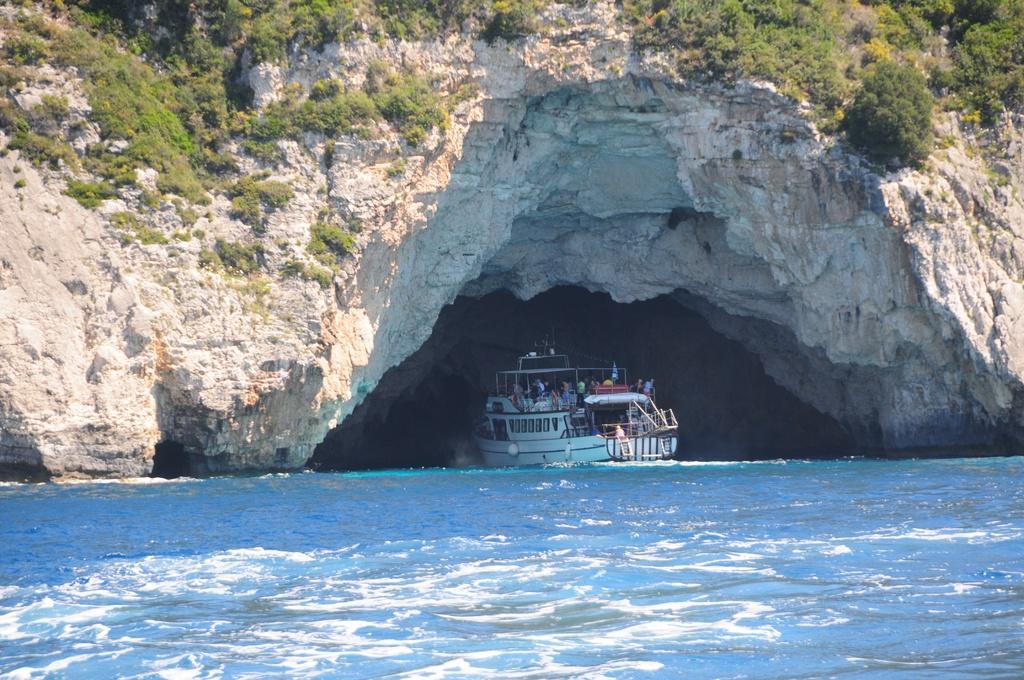How would you summarize this image in a sentence or two? In this picture we can see water at the bottom, there is a boat here, we can see some plants here. 